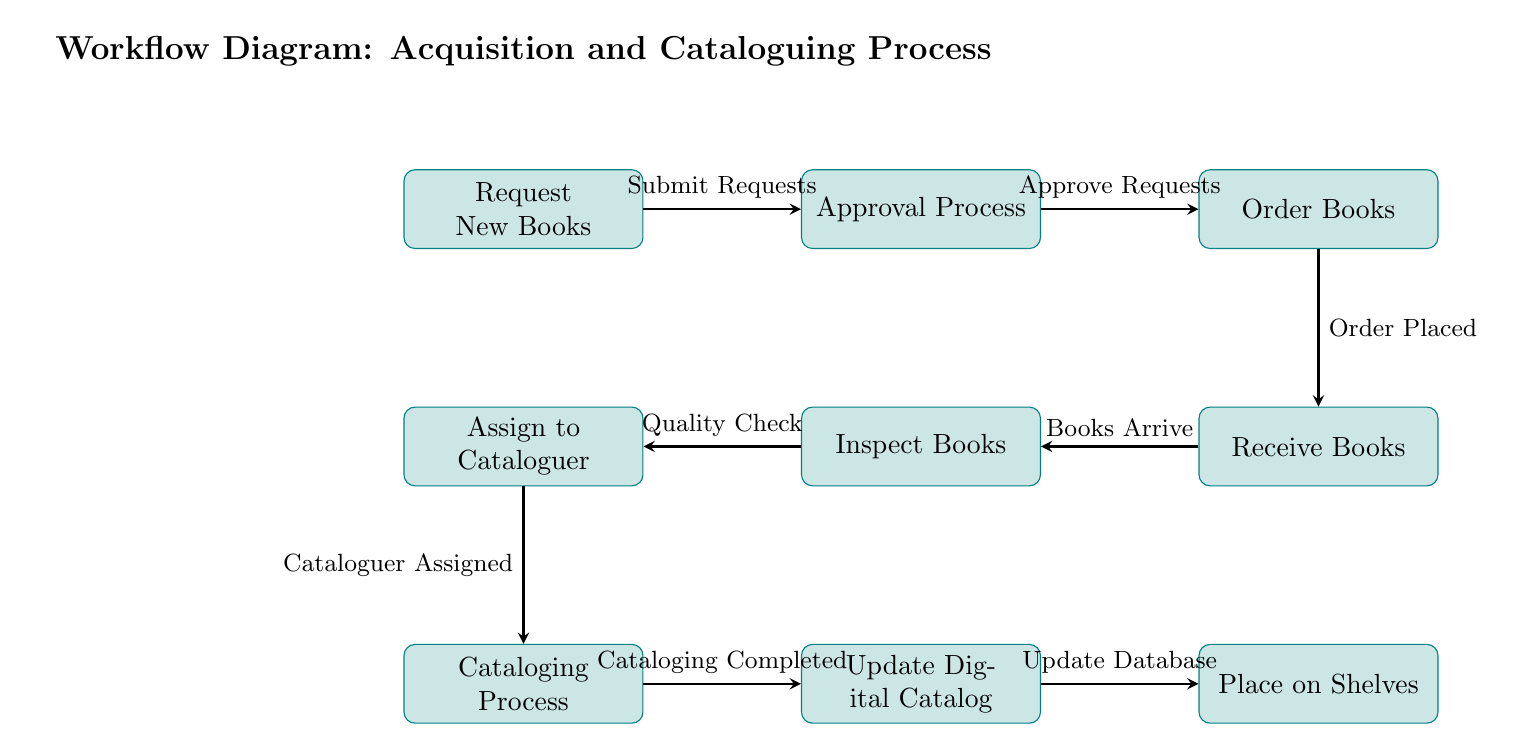What is the first step in the acquisition process? The first step in the acquisition process is "Request New Books," which is indicated as the initial node in the diagram.
Answer: Request New Books How many processes are shown in the diagram? By counting each of the rectangular nodes labeled as processes, there are a total of eight distinct processes depicted in the diagram.
Answer: Eight What follows the Approval Process? The flow from the Approval Process directly leads to the "Order Books" process, which is visually next to the Approval Process node.
Answer: Order Books What is the purpose of the "Inspect Books" step? The "Inspect Books" step serves as a quality check for the newly received books, ensuring they meet standards before moving forward in the process.
Answer: Quality Check What is the final step in this workflow? The workflow concludes with the step labeled "Place on Shelves," which is the last process indicated in the diagram.
Answer: Place on Shelves How are books received into the system? Books are received once the process labeled "Order Books" completes, leading into the "Receive Books" process where the actual receipt occurs.
Answer: Books Arrive What action occurs after the Cataloging Process? After the Cataloging Process is completed, the workflow moves to the "Update Digital Catalog," indicating the next required action in the sequence.
Answer: Update Digital Catalog Which process comes before assigning to a cataloguer? The "Inspect Books" process precedes the "Assign to Cataloguer," indicating that physical inspection is necessary before any cataloguer is allocated to a book.
Answer: Inspect Books 